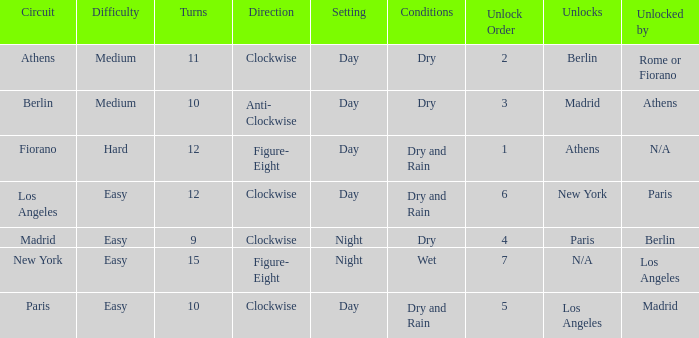What are the conditions for the athens circuit? Dry. 